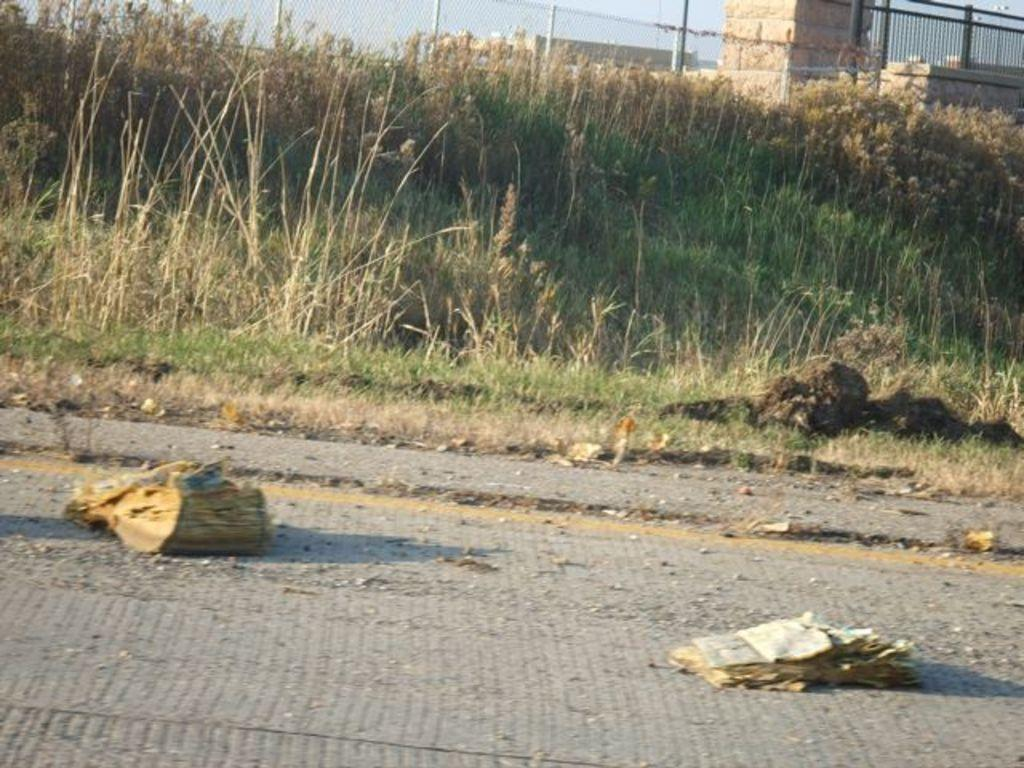What type of vegetation can be seen in the image? There is grass in the image. What structures are visible in the image? There are buildings in the image. What type of barrier is present in the image? There is a metal fence in the image. What objects are on the road in the image? There are papers on the road in the image. What type of ball is being used to play a game on the grass in the image? There is no ball or game being played in the image; it only features grass, buildings, a metal fence, and papers on the road. What type of apparel is the person wearing while playing with the ball on the grass in the image? There is no person or ball present in the image, so it is not possible to determine what type of apparel they might be wearing. 